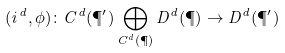<formula> <loc_0><loc_0><loc_500><loc_500>( i ^ { d } , \phi ) \colon C ^ { d } ( \P ^ { \prime } ) \bigoplus _ { C ^ { d } ( \P ) } D ^ { d } ( \P ) \rightarrow D ^ { d } ( \P ^ { \prime } )</formula> 